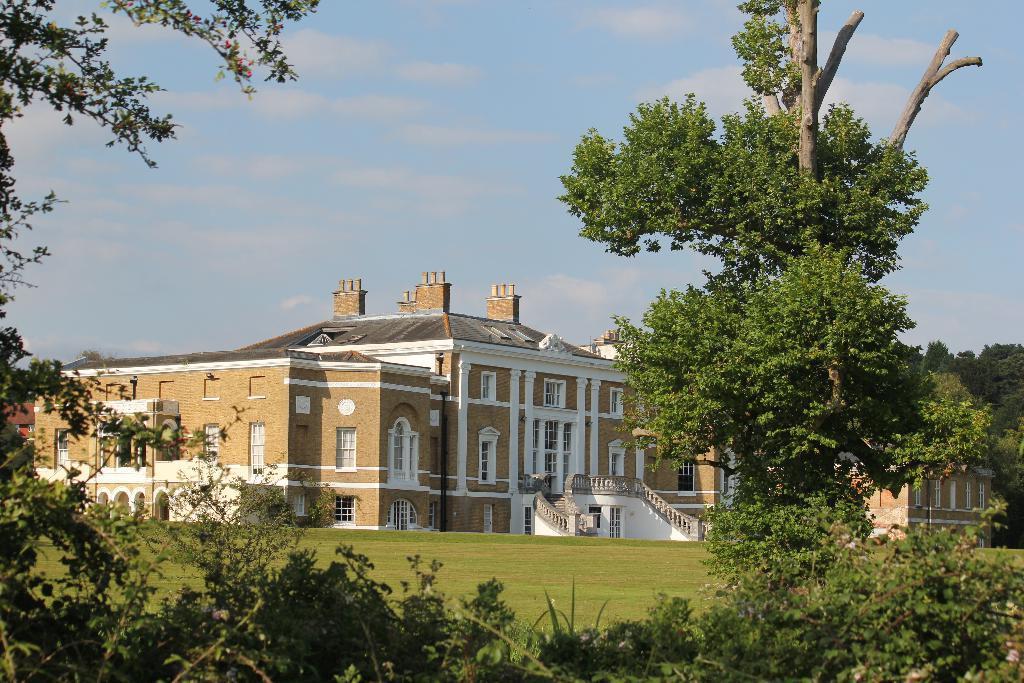Describe this image in one or two sentences. In this picture there is a building. At the bottom we can see plants and trees. At the top we can see sky and clouds. In front of the building we can see stairs and grass. On the building we can see windows, doors, glass and ventilation. 